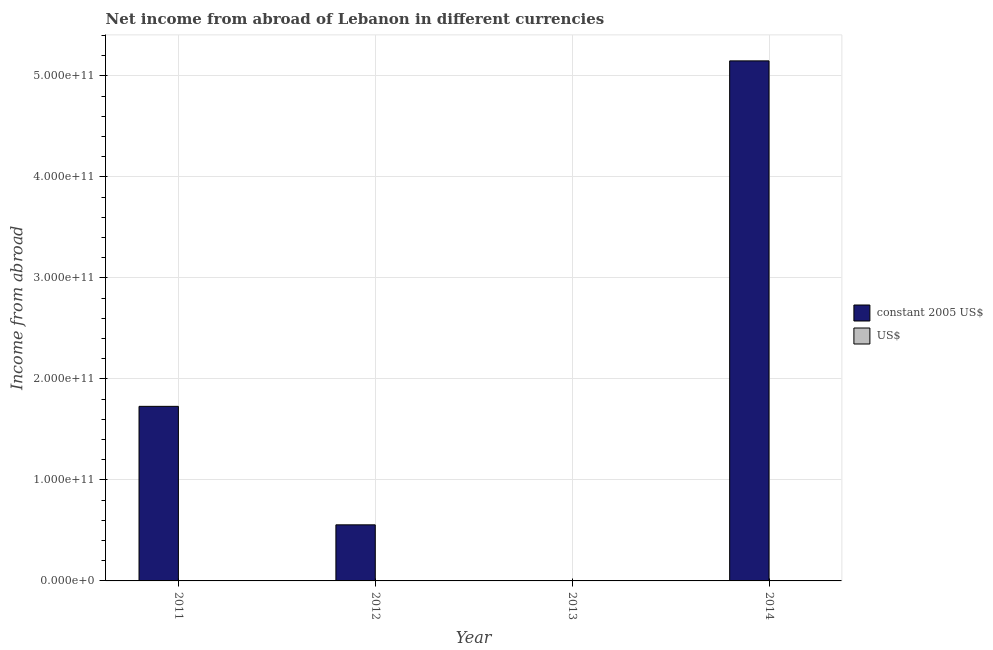Are the number of bars on each tick of the X-axis equal?
Provide a short and direct response. No. How many bars are there on the 3rd tick from the left?
Give a very brief answer. 0. How many bars are there on the 3rd tick from the right?
Ensure brevity in your answer.  2. What is the label of the 3rd group of bars from the left?
Make the answer very short. 2013. What is the income from abroad in us$ in 2012?
Give a very brief answer. 3.68e+07. Across all years, what is the maximum income from abroad in us$?
Provide a succinct answer. 3.42e+08. Across all years, what is the minimum income from abroad in constant 2005 us$?
Give a very brief answer. 0. What is the total income from abroad in us$ in the graph?
Your response must be concise. 4.93e+08. What is the difference between the income from abroad in constant 2005 us$ in 2012 and that in 2014?
Your answer should be compact. -4.59e+11. What is the difference between the income from abroad in constant 2005 us$ in 2012 and the income from abroad in us$ in 2013?
Your response must be concise. 5.55e+1. What is the average income from abroad in constant 2005 us$ per year?
Keep it short and to the point. 1.86e+11. In the year 2014, what is the difference between the income from abroad in constant 2005 us$ and income from abroad in us$?
Give a very brief answer. 0. What is the ratio of the income from abroad in us$ in 2012 to that in 2014?
Ensure brevity in your answer.  0.11. Is the income from abroad in us$ in 2012 less than that in 2014?
Offer a terse response. Yes. Is the difference between the income from abroad in constant 2005 us$ in 2011 and 2012 greater than the difference between the income from abroad in us$ in 2011 and 2012?
Provide a short and direct response. No. What is the difference between the highest and the second highest income from abroad in us$?
Your answer should be compact. 2.27e+08. What is the difference between the highest and the lowest income from abroad in us$?
Your response must be concise. 3.42e+08. In how many years, is the income from abroad in us$ greater than the average income from abroad in us$ taken over all years?
Your response must be concise. 1. Is the sum of the income from abroad in us$ in 2012 and 2014 greater than the maximum income from abroad in constant 2005 us$ across all years?
Offer a terse response. Yes. How many bars are there?
Your response must be concise. 6. How many years are there in the graph?
Provide a succinct answer. 4. What is the difference between two consecutive major ticks on the Y-axis?
Give a very brief answer. 1.00e+11. Are the values on the major ticks of Y-axis written in scientific E-notation?
Your answer should be compact. Yes. How are the legend labels stacked?
Offer a terse response. Vertical. What is the title of the graph?
Give a very brief answer. Net income from abroad of Lebanon in different currencies. Does "Young" appear as one of the legend labels in the graph?
Provide a short and direct response. No. What is the label or title of the Y-axis?
Ensure brevity in your answer.  Income from abroad. What is the Income from abroad of constant 2005 US$ in 2011?
Provide a short and direct response. 1.73e+11. What is the Income from abroad of US$ in 2011?
Your response must be concise. 1.15e+08. What is the Income from abroad in constant 2005 US$ in 2012?
Your response must be concise. 5.55e+1. What is the Income from abroad of US$ in 2012?
Give a very brief answer. 3.68e+07. What is the Income from abroad of constant 2005 US$ in 2014?
Make the answer very short. 5.15e+11. What is the Income from abroad of US$ in 2014?
Make the answer very short. 3.42e+08. Across all years, what is the maximum Income from abroad of constant 2005 US$?
Keep it short and to the point. 5.15e+11. Across all years, what is the maximum Income from abroad of US$?
Your answer should be compact. 3.42e+08. Across all years, what is the minimum Income from abroad of US$?
Provide a succinct answer. 0. What is the total Income from abroad of constant 2005 US$ in the graph?
Offer a terse response. 7.43e+11. What is the total Income from abroad in US$ in the graph?
Your answer should be very brief. 4.93e+08. What is the difference between the Income from abroad in constant 2005 US$ in 2011 and that in 2012?
Ensure brevity in your answer.  1.17e+11. What is the difference between the Income from abroad in US$ in 2011 and that in 2012?
Your answer should be compact. 7.78e+07. What is the difference between the Income from abroad of constant 2005 US$ in 2011 and that in 2014?
Provide a short and direct response. -3.42e+11. What is the difference between the Income from abroad of US$ in 2011 and that in 2014?
Make the answer very short. -2.27e+08. What is the difference between the Income from abroad in constant 2005 US$ in 2012 and that in 2014?
Give a very brief answer. -4.59e+11. What is the difference between the Income from abroad in US$ in 2012 and that in 2014?
Keep it short and to the point. -3.05e+08. What is the difference between the Income from abroad of constant 2005 US$ in 2011 and the Income from abroad of US$ in 2012?
Keep it short and to the point. 1.73e+11. What is the difference between the Income from abroad in constant 2005 US$ in 2011 and the Income from abroad in US$ in 2014?
Offer a terse response. 1.72e+11. What is the difference between the Income from abroad of constant 2005 US$ in 2012 and the Income from abroad of US$ in 2014?
Give a very brief answer. 5.52e+1. What is the average Income from abroad in constant 2005 US$ per year?
Offer a very short reply. 1.86e+11. What is the average Income from abroad of US$ per year?
Make the answer very short. 1.23e+08. In the year 2011, what is the difference between the Income from abroad of constant 2005 US$ and Income from abroad of US$?
Your response must be concise. 1.73e+11. In the year 2012, what is the difference between the Income from abroad in constant 2005 US$ and Income from abroad in US$?
Provide a succinct answer. 5.55e+1. In the year 2014, what is the difference between the Income from abroad of constant 2005 US$ and Income from abroad of US$?
Make the answer very short. 5.15e+11. What is the ratio of the Income from abroad in constant 2005 US$ in 2011 to that in 2012?
Offer a very short reply. 3.11. What is the ratio of the Income from abroad of US$ in 2011 to that in 2012?
Provide a succinct answer. 3.11. What is the ratio of the Income from abroad in constant 2005 US$ in 2011 to that in 2014?
Offer a terse response. 0.34. What is the ratio of the Income from abroad in US$ in 2011 to that in 2014?
Provide a succinct answer. 0.34. What is the ratio of the Income from abroad in constant 2005 US$ in 2012 to that in 2014?
Make the answer very short. 0.11. What is the ratio of the Income from abroad in US$ in 2012 to that in 2014?
Give a very brief answer. 0.11. What is the difference between the highest and the second highest Income from abroad in constant 2005 US$?
Ensure brevity in your answer.  3.42e+11. What is the difference between the highest and the second highest Income from abroad in US$?
Ensure brevity in your answer.  2.27e+08. What is the difference between the highest and the lowest Income from abroad of constant 2005 US$?
Keep it short and to the point. 5.15e+11. What is the difference between the highest and the lowest Income from abroad of US$?
Keep it short and to the point. 3.42e+08. 